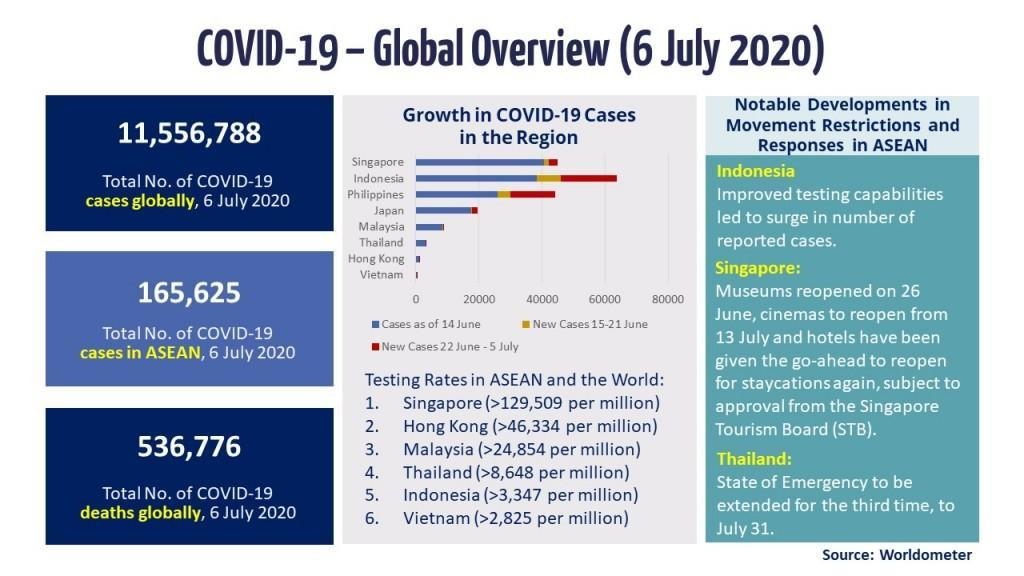Which ASEAN country has reported the highest number of COVID-19 cases as of 14 June 2020?
Answer the question with a short phrase. Singapore What is the total number of COVID-19 cases globally as of 6 July 2020? 11,556,788 What is the COVID-19 testing rate in Malaysia as of 6 July 2020? (>24,854 per million) Which ASEAN country has reported the least number of COVID-19 cases as of 14 June 2020? Vietnam What is the total number of COVID-19 cases in ASEAN as of 6 July 2020? 165,625 What is the total number of COVID-19 deaths globally as of 6 July 2020? 536,776 